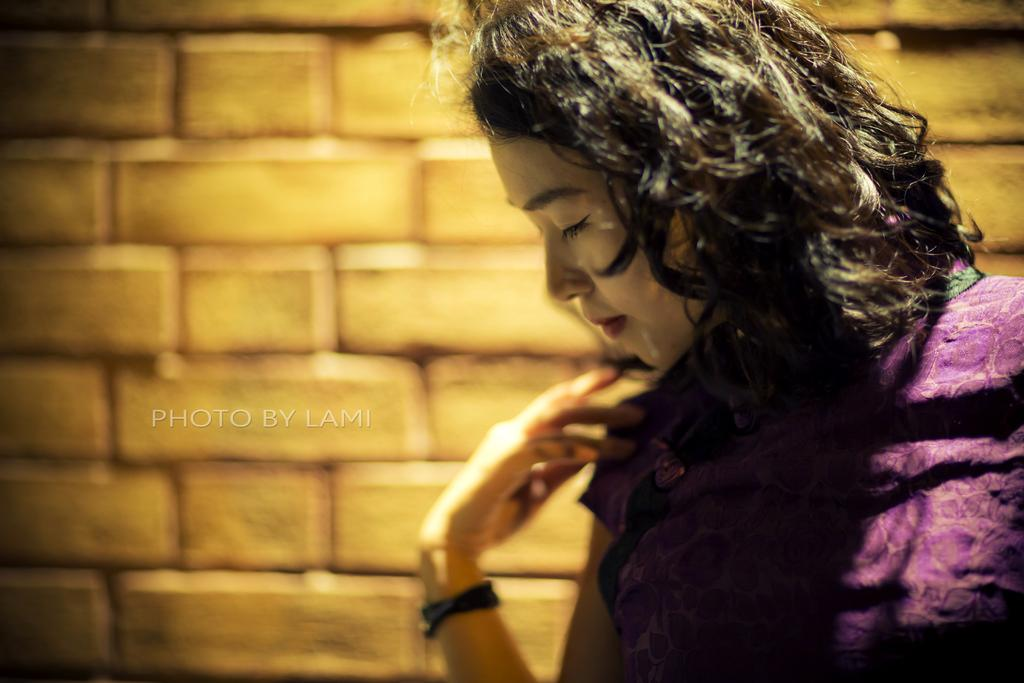What is the main subject of the image? The main subject of the image is a woman standing. What is the woman wearing in the image? The woman is wearing a violet dress and a wrist watch. What can be seen in the background of the image? There is a wall visible in the image. Is there any additional information about the image itself? Yes, there is a watermark on the image. What book is the woman holding in the image? There is no book visible in the image; the woman is not holding any book. What type of event is the woman attending in the image? There is no indication of an event in the image; it simply shows a woman standing. 